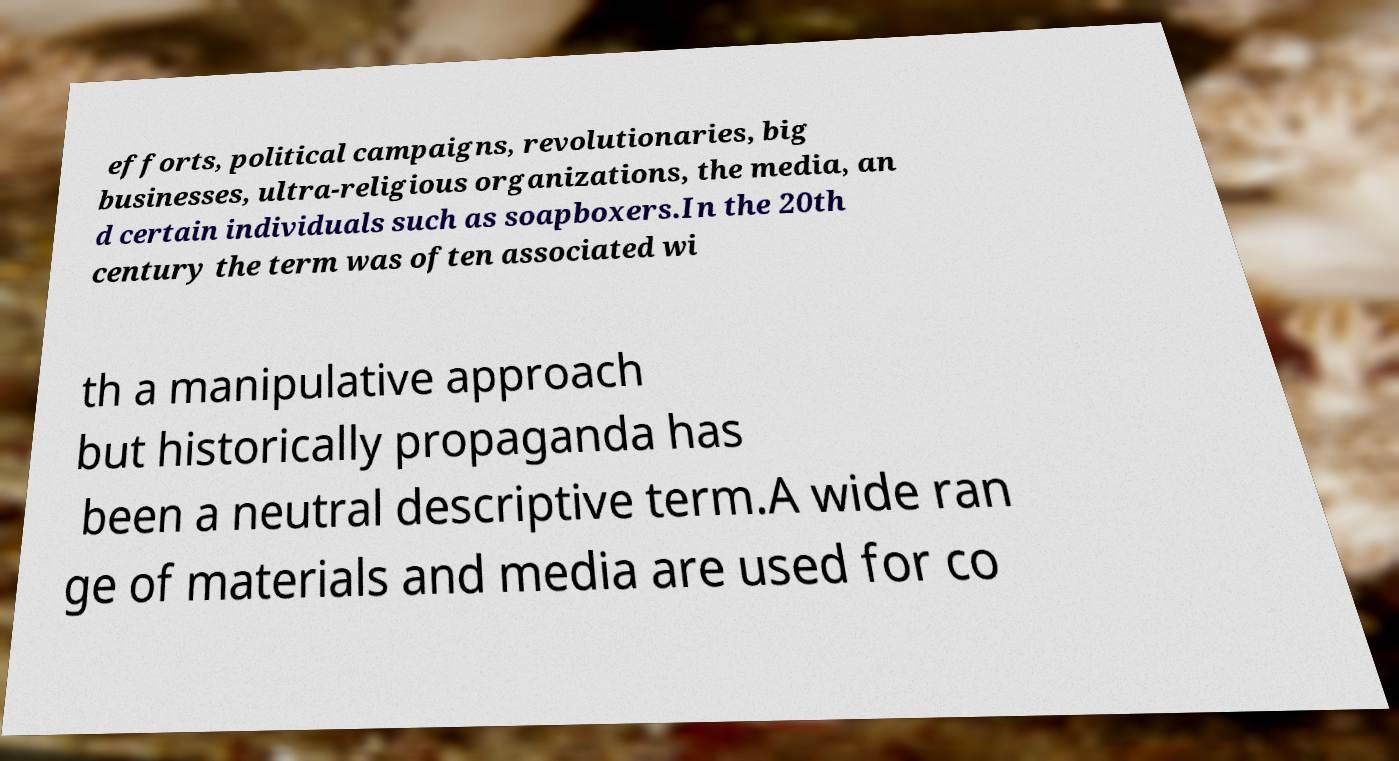Please read and relay the text visible in this image. What does it say? efforts, political campaigns, revolutionaries, big businesses, ultra-religious organizations, the media, an d certain individuals such as soapboxers.In the 20th century the term was often associated wi th a manipulative approach but historically propaganda has been a neutral descriptive term.A wide ran ge of materials and media are used for co 